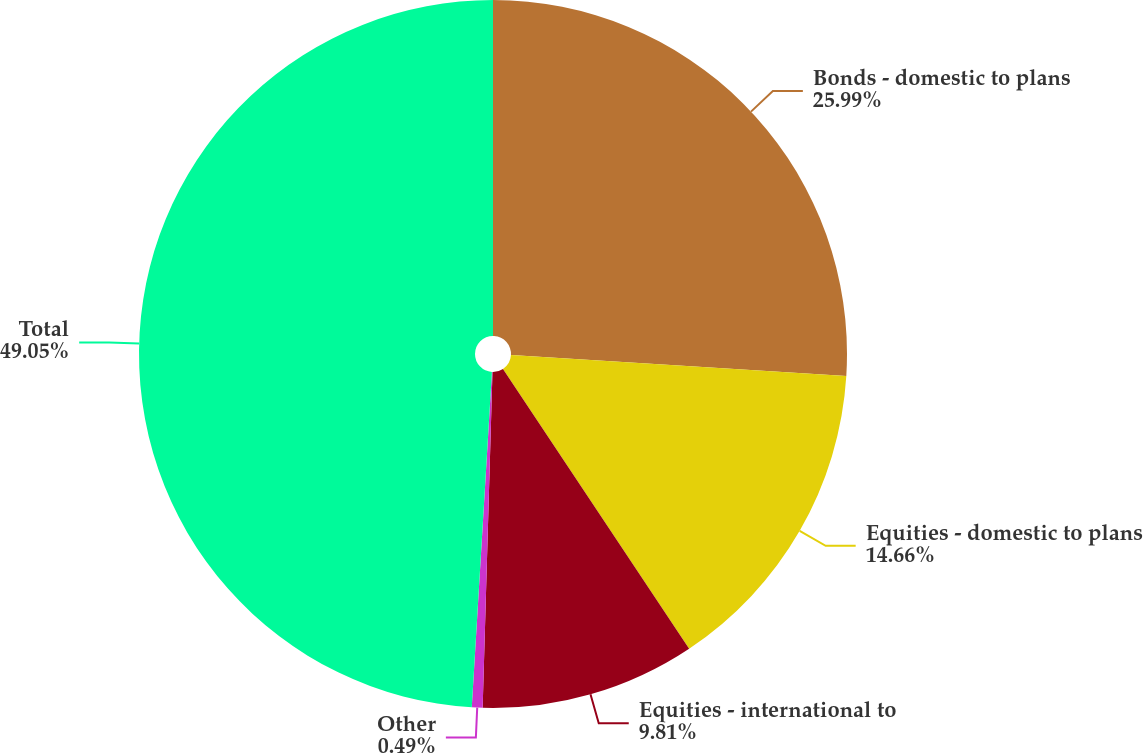Convert chart. <chart><loc_0><loc_0><loc_500><loc_500><pie_chart><fcel>Bonds - domestic to plans<fcel>Equities - domestic to plans<fcel>Equities - international to<fcel>Other<fcel>Total<nl><fcel>25.99%<fcel>14.66%<fcel>9.81%<fcel>0.49%<fcel>49.04%<nl></chart> 